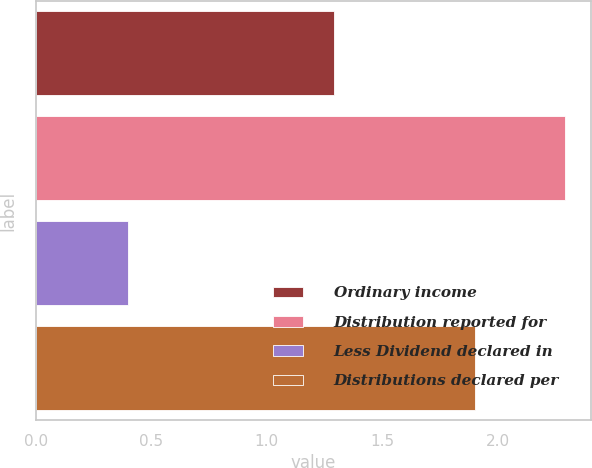Convert chart. <chart><loc_0><loc_0><loc_500><loc_500><bar_chart><fcel>Ordinary income<fcel>Distribution reported for<fcel>Less Dividend declared in<fcel>Distributions declared per<nl><fcel>1.29<fcel>2.29<fcel>0.4<fcel>1.9<nl></chart> 